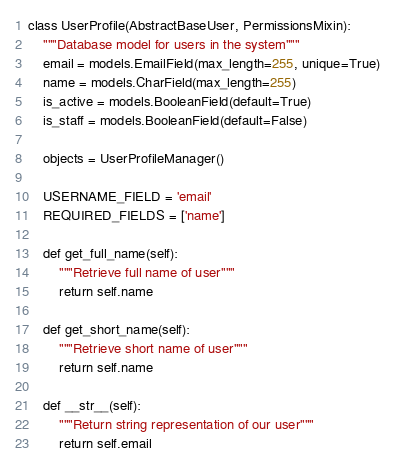<code> <loc_0><loc_0><loc_500><loc_500><_Python_>class UserProfile(AbstractBaseUser, PermissionsMixin):
    """Database model for users in the system"""
    email = models.EmailField(max_length=255, unique=True)
    name = models.CharField(max_length=255)
    is_active = models.BooleanField(default=True)
    is_staff = models.BooleanField(default=False)

    objects = UserProfileManager()

    USERNAME_FIELD = 'email'
    REQUIRED_FIELDS = ['name']

    def get_full_name(self):
        """Retrieve full name of user"""
        return self.name

    def get_short_name(self):
        """Retrieve short name of user"""
        return self.name

    def __str__(self):
        """Return string representation of our user"""
        return self.email
</code> 